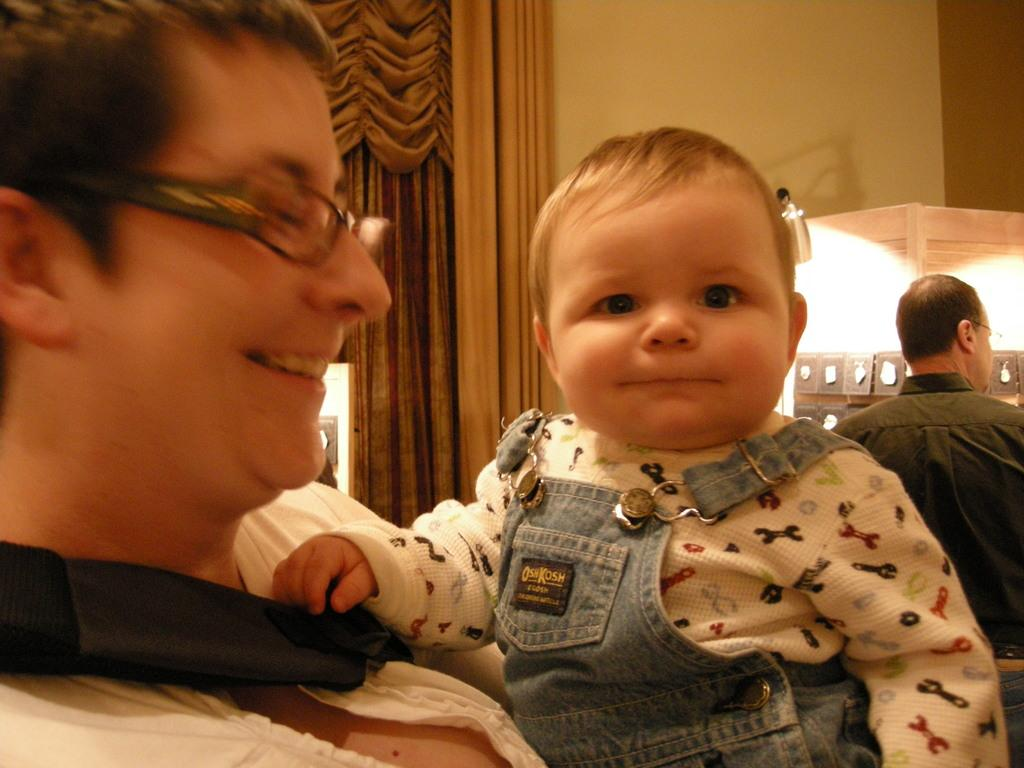Who or what is located in the foreground of the image? There is a person and a baby in the foreground of the image. What can be seen in the background of the image? There are curtains, at least one person, and some objects in the background of the image. How does the baby's neck increase in length in the image? The baby's neck does not increase in length in the image; it remains the same. What is the baby's wealth status in the image? There is no information about the baby's wealth status in the image. 